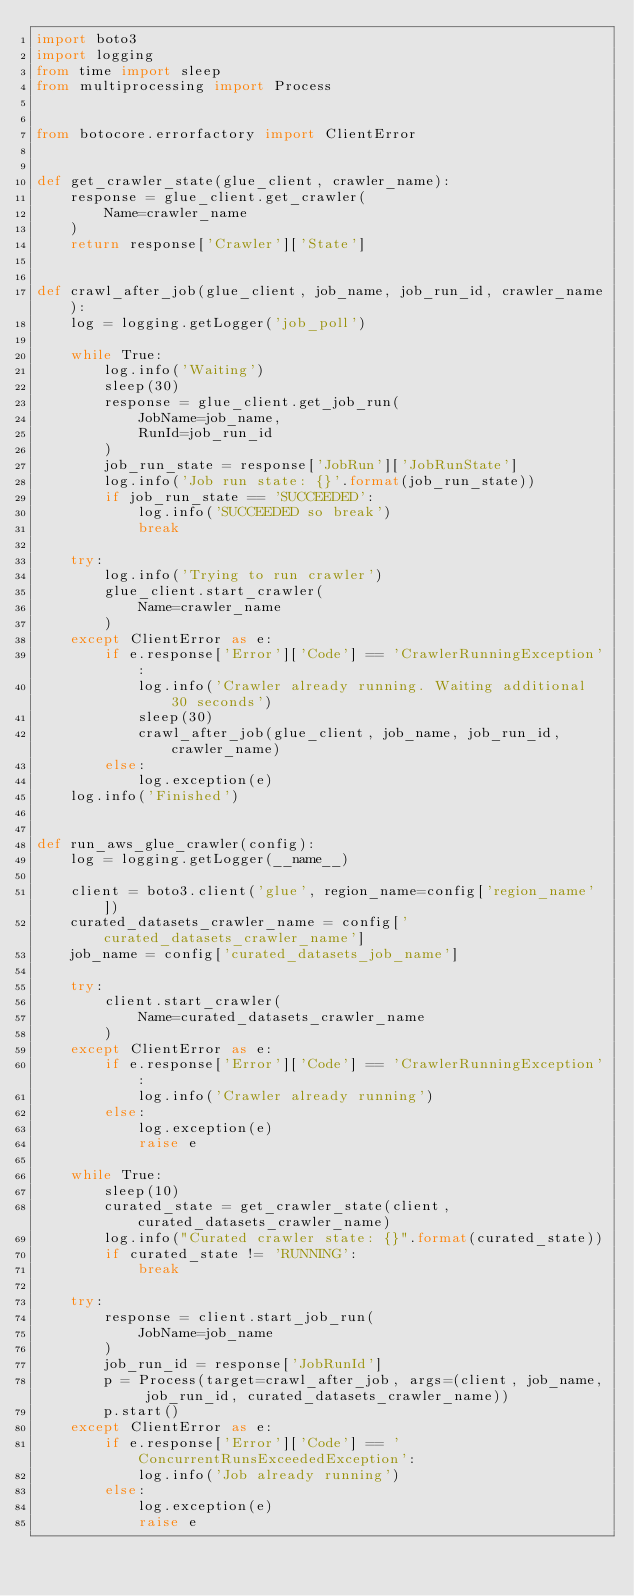<code> <loc_0><loc_0><loc_500><loc_500><_Python_>import boto3
import logging
from time import sleep
from multiprocessing import Process


from botocore.errorfactory import ClientError


def get_crawler_state(glue_client, crawler_name):
    response = glue_client.get_crawler(
        Name=crawler_name
    )
    return response['Crawler']['State']


def crawl_after_job(glue_client, job_name, job_run_id, crawler_name):
    log = logging.getLogger('job_poll')

    while True:
        log.info('Waiting')
        sleep(30)
        response = glue_client.get_job_run(
            JobName=job_name,
            RunId=job_run_id
        )
        job_run_state = response['JobRun']['JobRunState']
        log.info('Job run state: {}'.format(job_run_state))
        if job_run_state == 'SUCCEEDED':
            log.info('SUCCEEDED so break')
            break

    try:
        log.info('Trying to run crawler')
        glue_client.start_crawler(
            Name=crawler_name
        )
    except ClientError as e:
        if e.response['Error']['Code'] == 'CrawlerRunningException':
            log.info('Crawler already running. Waiting additional 30 seconds')
            sleep(30)
            crawl_after_job(glue_client, job_name, job_run_id, crawler_name)
        else:
            log.exception(e)
    log.info('Finished')


def run_aws_glue_crawler(config):
    log = logging.getLogger(__name__)

    client = boto3.client('glue', region_name=config['region_name'])
    curated_datasets_crawler_name = config['curated_datasets_crawler_name']
    job_name = config['curated_datasets_job_name']

    try:
        client.start_crawler(
            Name=curated_datasets_crawler_name
        )
    except ClientError as e:
        if e.response['Error']['Code'] == 'CrawlerRunningException':
            log.info('Crawler already running')
        else:
            log.exception(e)
            raise e

    while True:
        sleep(10)
        curated_state = get_crawler_state(client, curated_datasets_crawler_name)
        log.info("Curated crawler state: {}".format(curated_state))
        if curated_state != 'RUNNING':
            break

    try:
        response = client.start_job_run(
            JobName=job_name
        )
        job_run_id = response['JobRunId']
        p = Process(target=crawl_after_job, args=(client, job_name, job_run_id, curated_datasets_crawler_name))
        p.start()
    except ClientError as e:
        if e.response['Error']['Code'] == 'ConcurrentRunsExceededException':
            log.info('Job already running')
        else:
            log.exception(e)
            raise e
</code> 